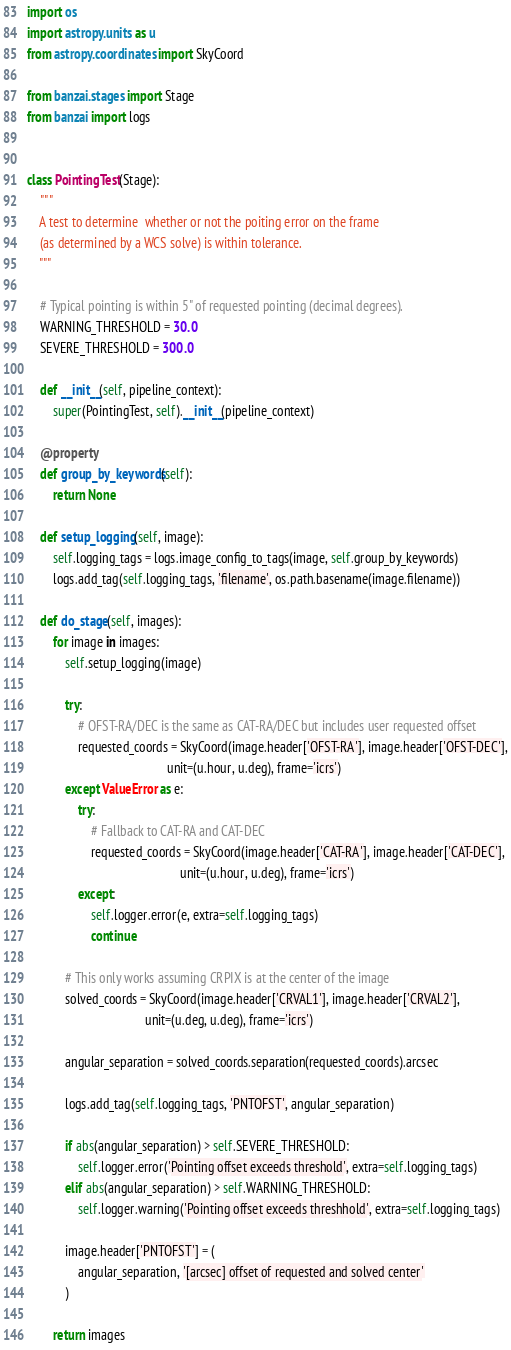<code> <loc_0><loc_0><loc_500><loc_500><_Python_>import os
import astropy.units as u
from astropy.coordinates import SkyCoord

from banzai.stages import Stage
from banzai import logs


class PointingTest(Stage):
    """
    A test to determine  whether or not the poiting error on the frame
    (as determined by a WCS solve) is within tolerance.
    """

    # Typical pointing is within 5" of requested pointing (decimal degrees).
    WARNING_THRESHOLD = 30.0
    SEVERE_THRESHOLD = 300.0

    def __init__(self, pipeline_context):
        super(PointingTest, self).__init__(pipeline_context)

    @property
    def group_by_keywords(self):
        return None

    def setup_logging(self, image):
        self.logging_tags = logs.image_config_to_tags(image, self.group_by_keywords)
        logs.add_tag(self.logging_tags, 'filename', os.path.basename(image.filename))

    def do_stage(self, images):
        for image in images:
            self.setup_logging(image)

            try:
                # OFST-RA/DEC is the same as CAT-RA/DEC but includes user requested offset
                requested_coords = SkyCoord(image.header['OFST-RA'], image.header['OFST-DEC'],
                                            unit=(u.hour, u.deg), frame='icrs')
            except ValueError as e:
                try:
                    # Fallback to CAT-RA and CAT-DEC
                    requested_coords = SkyCoord(image.header['CAT-RA'], image.header['CAT-DEC'],
                                                unit=(u.hour, u.deg), frame='icrs')
                except:
                    self.logger.error(e, extra=self.logging_tags)
                    continue

            # This only works assuming CRPIX is at the center of the image
            solved_coords = SkyCoord(image.header['CRVAL1'], image.header['CRVAL2'],
                                     unit=(u.deg, u.deg), frame='icrs')

            angular_separation = solved_coords.separation(requested_coords).arcsec

            logs.add_tag(self.logging_tags, 'PNTOFST', angular_separation)

            if abs(angular_separation) > self.SEVERE_THRESHOLD:
                self.logger.error('Pointing offset exceeds threshold', extra=self.logging_tags)
            elif abs(angular_separation) > self.WARNING_THRESHOLD:
                self.logger.warning('Pointing offset exceeds threshhold', extra=self.logging_tags)

            image.header['PNTOFST'] = (
                angular_separation, '[arcsec] offset of requested and solved center'
            )

        return images
</code> 